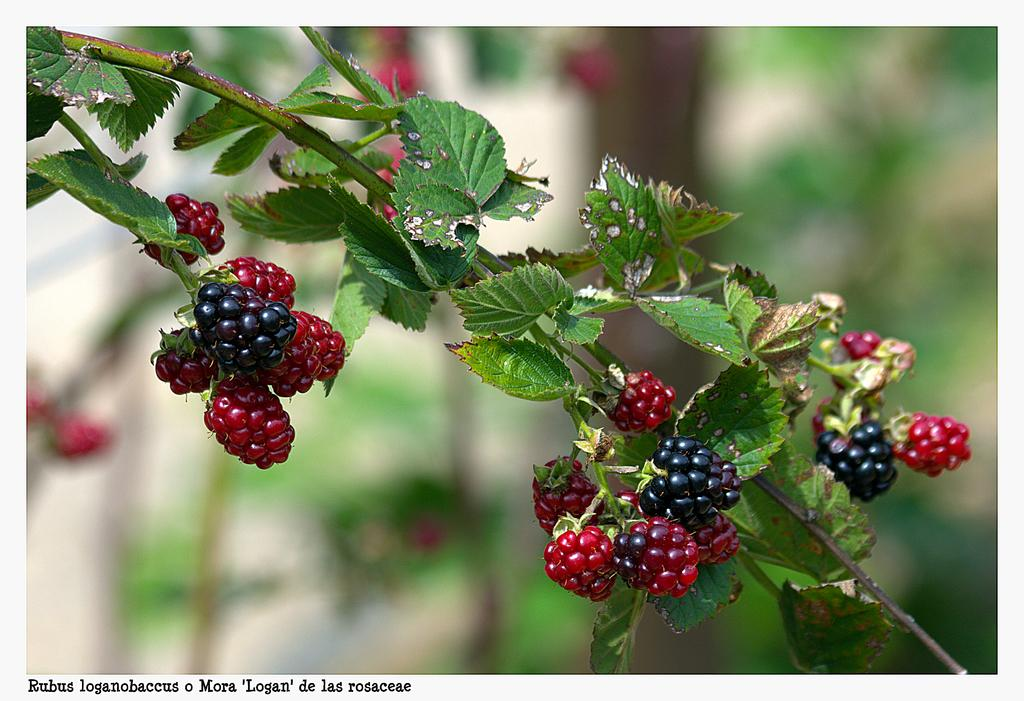Where was the image taken? The image was taken outdoors. What can be seen in the background of the image? There are trees in the background of the image. What is the main subject in the middle of the image? There is a stem with green leaves in the middle of the image. What is attached to the stem? There are berries on the stem. How many eyes can be seen on the tree in the image? There are no eyes visible in the image, as it features a stem with green leaves and berries, not a tree with eyes. 